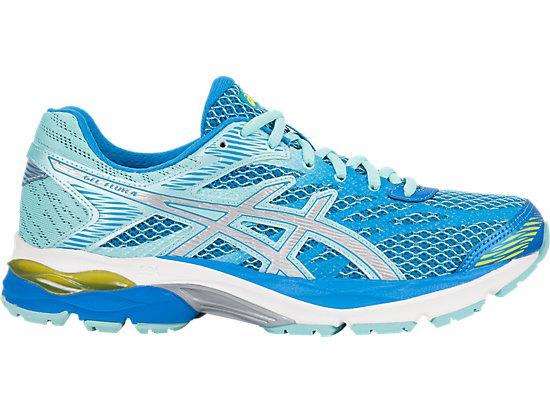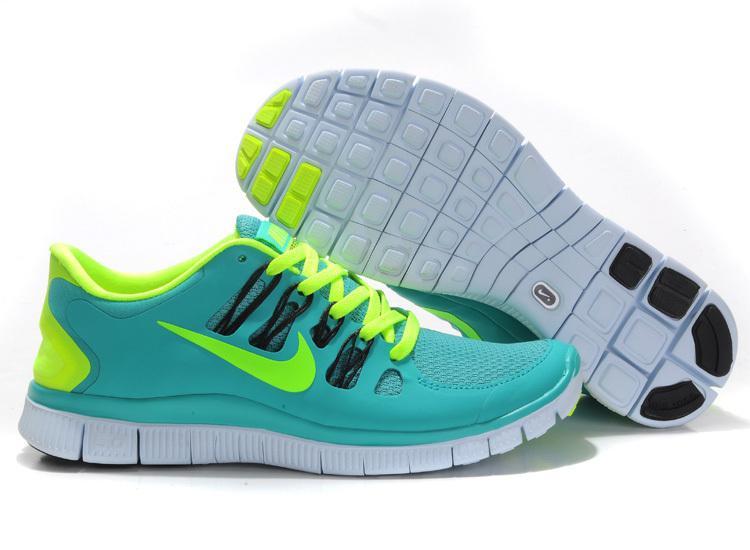The first image is the image on the left, the second image is the image on the right. Assess this claim about the two images: "Exactly three shoes are shown, a pair in one image with one turned over with visible sole treads, while a single shoe in the other image is a different color scheme and design.". Correct or not? Answer yes or no. Yes. The first image is the image on the left, the second image is the image on the right. For the images displayed, is the sentence "At least one sneaker incorporates purple in its design." factually correct? Answer yes or no. No. 